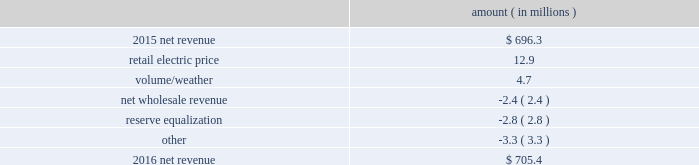2016 compared to 2015 net revenue consists of operating revenues net of : 1 ) fuel , fuel-related expenses , and gas purchased for resale , 2 ) purchased power expenses , and 3 ) other regulatory charges ( credits ) .
Following is an analysis of the change in net revenue comparing 2016 to 2015 .
Amount ( in millions ) .
The retail electric price variance is primarily due to a $ 19.4 million net annual increase in revenues , as approved by the mpsc , effective with the first billing cycle of july 2016 , and an increase in revenues collected through the storm damage rider . a0 see note 2 to the financial statements for more discussion of the formula rate plan and the storm damage rider .
The volume/weather variance is primarily due to an increase of 153 gwh , or 1% ( 1 % ) , in billed electricity usage , including an increase in industrial usage , partially offset by the effect of less favorable weather on residential and commercial sales .
The increase in industrial usage is primarily due to expansion projects in the pulp and paper industry , increased demand for existing customers , primarily in the metals industry , and new customers in the wood products industry .
The net wholesale revenue variance is primarily due to entergy mississippi 2019s exit from the system agreement in november 2015 .
The reserve equalization revenue variance is primarily due to the absence of reserve equalization revenue as compared to the same period in 2015 resulting from entergy mississippi 2019s exit from the system agreement in november other income statement variances 2017 compared to 2016 other operation and maintenance expenses decreased primarily due to : 2022 a decrease of $ 12 million in fossil-fueled generation expenses primarily due to lower long-term service agreement costs and a lower scope of work done during plant outages in 2017 as compared to the same period in 2016 ; and 2022 a decrease of $ 3.6 million in storm damage provisions .
See note 2 to the financial statements for a discussion on storm cost recovery .
The decrease was partially offset by an increase of $ 4.8 million in energy efficiency costs and an increase of $ 2.7 million in compensation and benefits costs primarily due to higher incentive-based compensation accruals in 2017 as compared to the prior year .
Entergy mississippi , inc .
Management 2019s financial discussion and analysis .
The change in retail electric price accounts for what percent of revenue increase? 
Computations: (12.9 / 19.4)
Answer: 0.66495. 